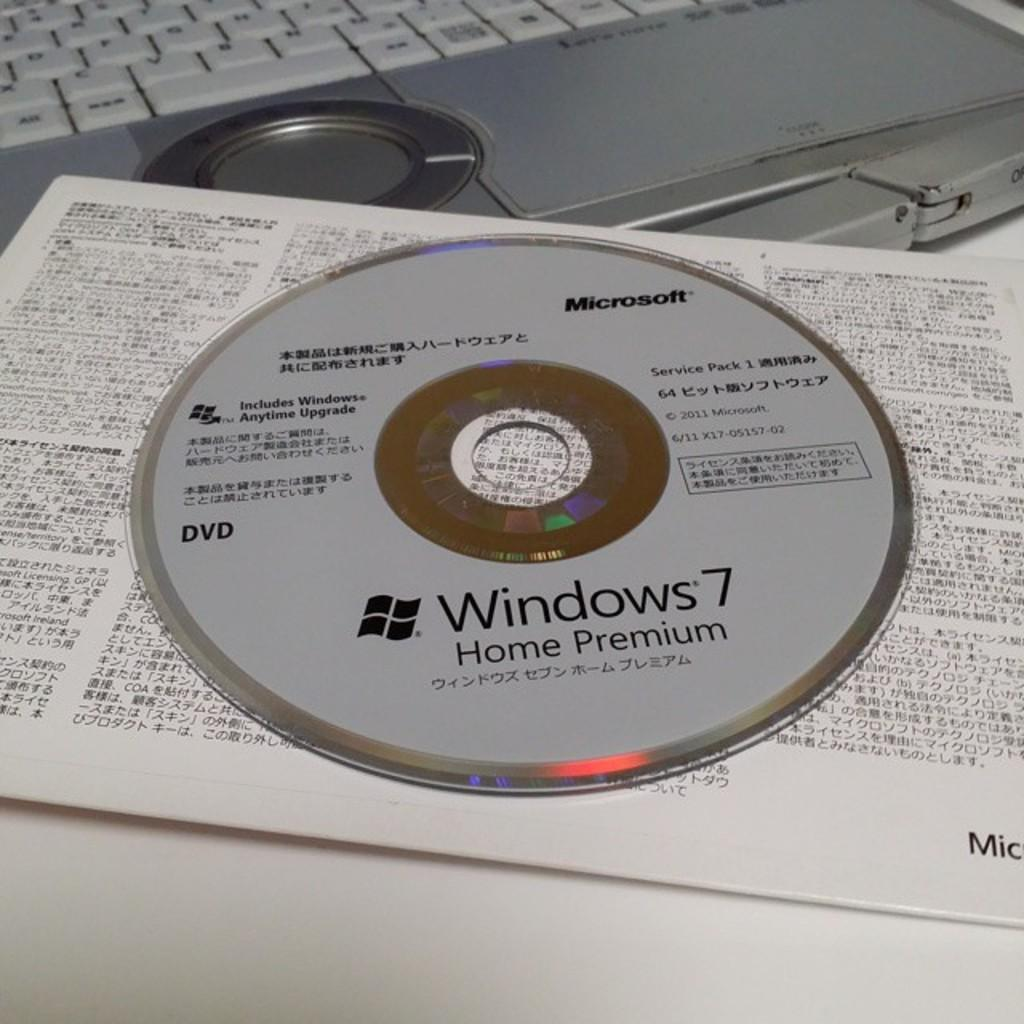What type of storage device is visible in the image? There is an SD card and a CD in the image. What is the primary device in the image? The laptop keyboard is visible in the image. What is the color of the table where the items are placed? The items are on a white table. What is written on the CD and the SD card? Something is written on the CD and the SD card. What type of discussion is taking place between the grandmother and the eye in the image? There is no grandmother or eye present in the image; it only features an SD card, a CD, a laptop keyboard, and a white table. 